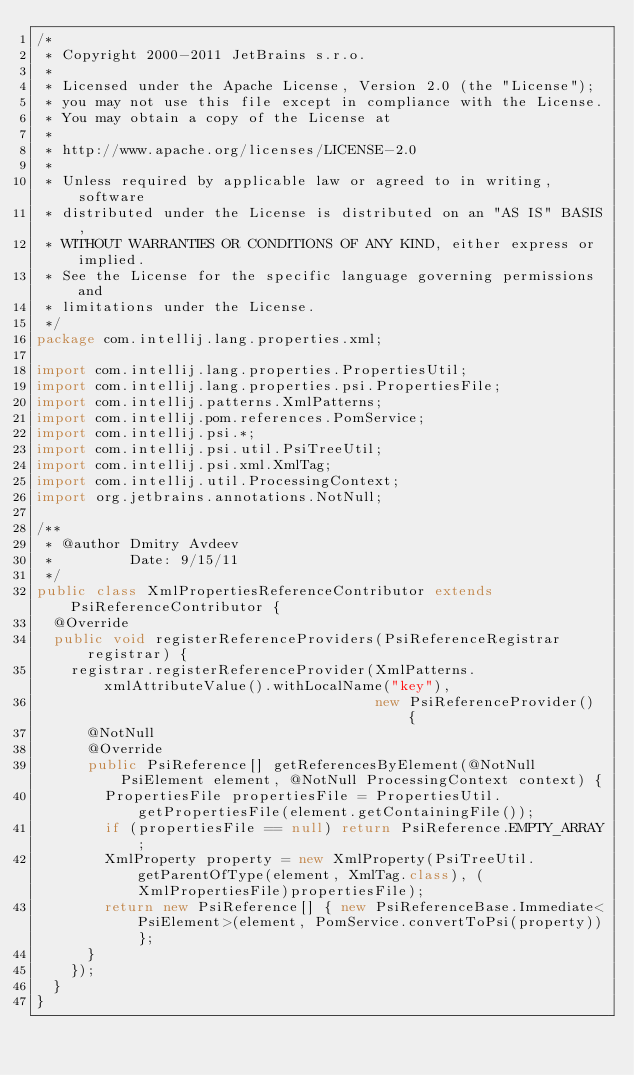Convert code to text. <code><loc_0><loc_0><loc_500><loc_500><_Java_>/*
 * Copyright 2000-2011 JetBrains s.r.o.
 *
 * Licensed under the Apache License, Version 2.0 (the "License");
 * you may not use this file except in compliance with the License.
 * You may obtain a copy of the License at
 *
 * http://www.apache.org/licenses/LICENSE-2.0
 *
 * Unless required by applicable law or agreed to in writing, software
 * distributed under the License is distributed on an "AS IS" BASIS,
 * WITHOUT WARRANTIES OR CONDITIONS OF ANY KIND, either express or implied.
 * See the License for the specific language governing permissions and
 * limitations under the License.
 */
package com.intellij.lang.properties.xml;

import com.intellij.lang.properties.PropertiesUtil;
import com.intellij.lang.properties.psi.PropertiesFile;
import com.intellij.patterns.XmlPatterns;
import com.intellij.pom.references.PomService;
import com.intellij.psi.*;
import com.intellij.psi.util.PsiTreeUtil;
import com.intellij.psi.xml.XmlTag;
import com.intellij.util.ProcessingContext;
import org.jetbrains.annotations.NotNull;

/**
 * @author Dmitry Avdeev
 *         Date: 9/15/11
 */
public class XmlPropertiesReferenceContributor extends PsiReferenceContributor {
  @Override
  public void registerReferenceProviders(PsiReferenceRegistrar registrar) {
    registrar.registerReferenceProvider(XmlPatterns.xmlAttributeValue().withLocalName("key"),
                                        new PsiReferenceProvider() {
      @NotNull
      @Override
      public PsiReference[] getReferencesByElement(@NotNull PsiElement element, @NotNull ProcessingContext context) {
        PropertiesFile propertiesFile = PropertiesUtil.getPropertiesFile(element.getContainingFile());
        if (propertiesFile == null) return PsiReference.EMPTY_ARRAY;
        XmlProperty property = new XmlProperty(PsiTreeUtil.getParentOfType(element, XmlTag.class), (XmlPropertiesFile)propertiesFile);
        return new PsiReference[] { new PsiReferenceBase.Immediate<PsiElement>(element, PomService.convertToPsi(property))};
      }
    });
  }
}
</code> 